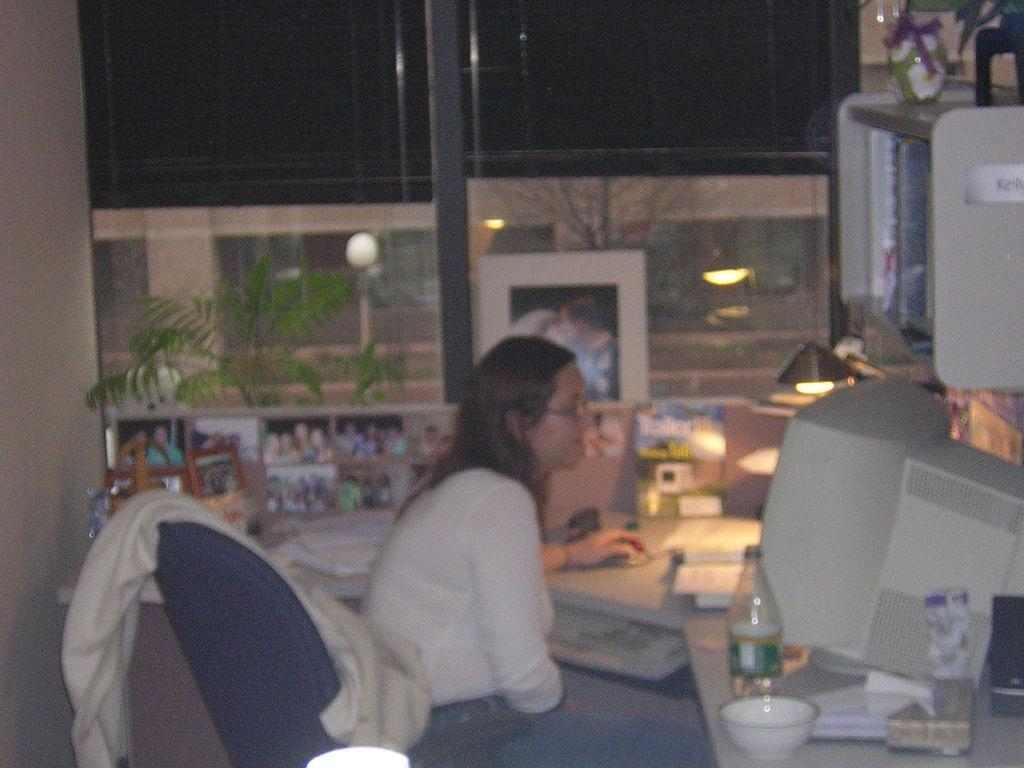Who is the main subject in the image? There is a woman in the image. What is the woman doing in the image? The woman is sitting on a chair. What is in front of the woman? There is a table in front of the woman. What can be seen on the table? There are many things on the table. What is visible in the background of the image? There is a window in the image. What type of rice can be seen growing in the image? There is no rice visible in the image; it features a woman sitting on a chair with a table and a window in the background. 